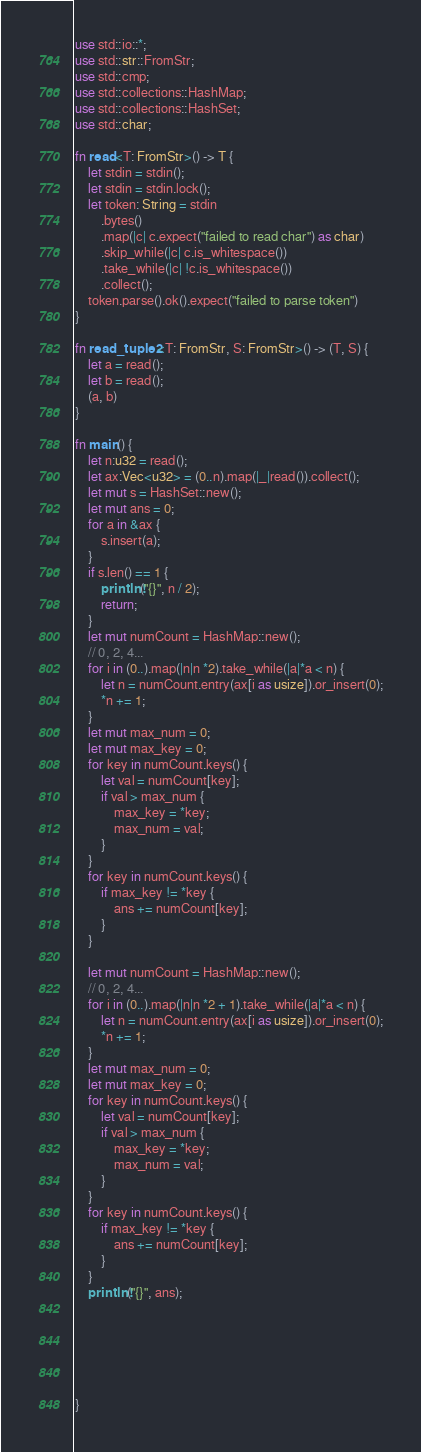Convert code to text. <code><loc_0><loc_0><loc_500><loc_500><_Rust_>use std::io::*;
use std::str::FromStr;
use std::cmp;
use std::collections::HashMap;
use std::collections::HashSet;
use std::char;

fn read<T: FromStr>() -> T {
    let stdin = stdin();
    let stdin = stdin.lock();
    let token: String = stdin
        .bytes()
        .map(|c| c.expect("failed to read char") as char) 
        .skip_while(|c| c.is_whitespace())
        .take_while(|c| !c.is_whitespace())
        .collect();
    token.parse().ok().expect("failed to parse token")
}

fn read_tuple2<T: FromStr, S: FromStr>() -> (T, S) {
    let a = read();
    let b = read();
    (a, b)
}

fn main() {
    let n:u32 = read();
    let ax:Vec<u32> = (0..n).map(|_|read()).collect();
    let mut s = HashSet::new();
    let mut ans = 0;
    for a in &ax {
        s.insert(a);
    }
    if s.len() == 1 {
        println!("{}", n / 2);
        return;
    }
    let mut numCount = HashMap::new();
    // 0, 2, 4...
    for i in (0..).map(|n|n *2).take_while(|a|*a < n) {
        let n = numCount.entry(ax[i as usize]).or_insert(0);
        *n += 1;
    }
    let mut max_num = 0;
    let mut max_key = 0;
    for key in numCount.keys() {
        let val = numCount[key];
        if val > max_num {
            max_key = *key;
            max_num = val;
        }
    }
    for key in numCount.keys() {
        if max_key != *key {
            ans += numCount[key];
        }
    }

    let mut numCount = HashMap::new();
    // 0, 2, 4...
    for i in (0..).map(|n|n *2 + 1).take_while(|a|*a < n) {
        let n = numCount.entry(ax[i as usize]).or_insert(0);
        *n += 1;
    }
    let mut max_num = 0;
    let mut max_key = 0;
    for key in numCount.keys() {
        let val = numCount[key];
        if val > max_num {
            max_key = *key;
            max_num = val;
        }
    }
    for key in numCount.keys() {
        if max_key != *key {
            ans += numCount[key];
        }
    }
    println!("{}", ans);






}

</code> 